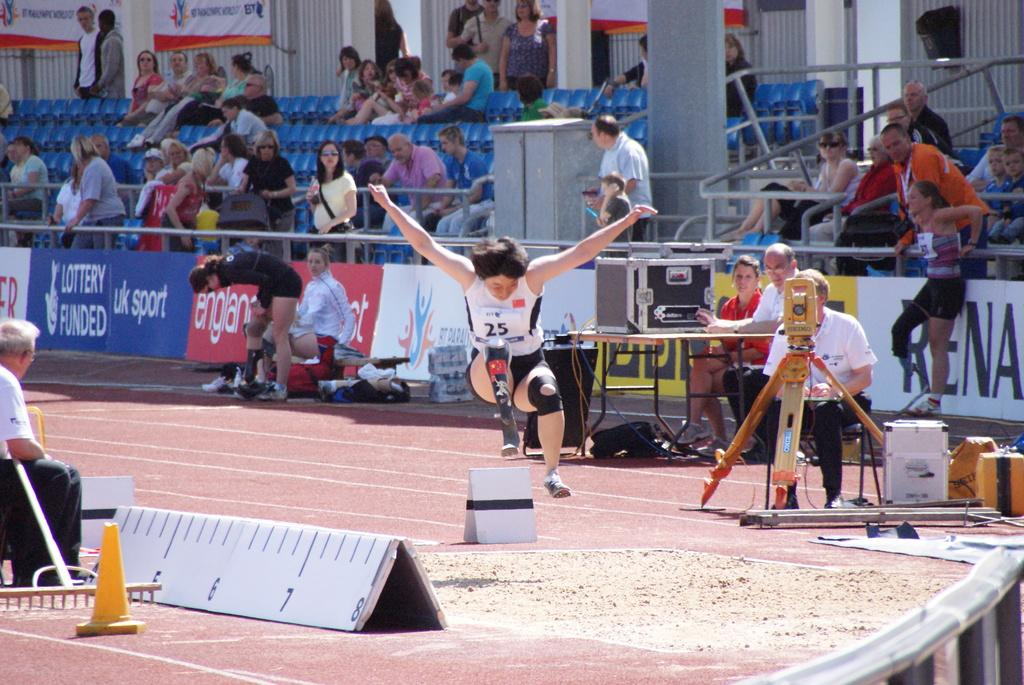Provide a one-sentence caption for the provided image. The athlete wearing bib number 25 does the long jump. 